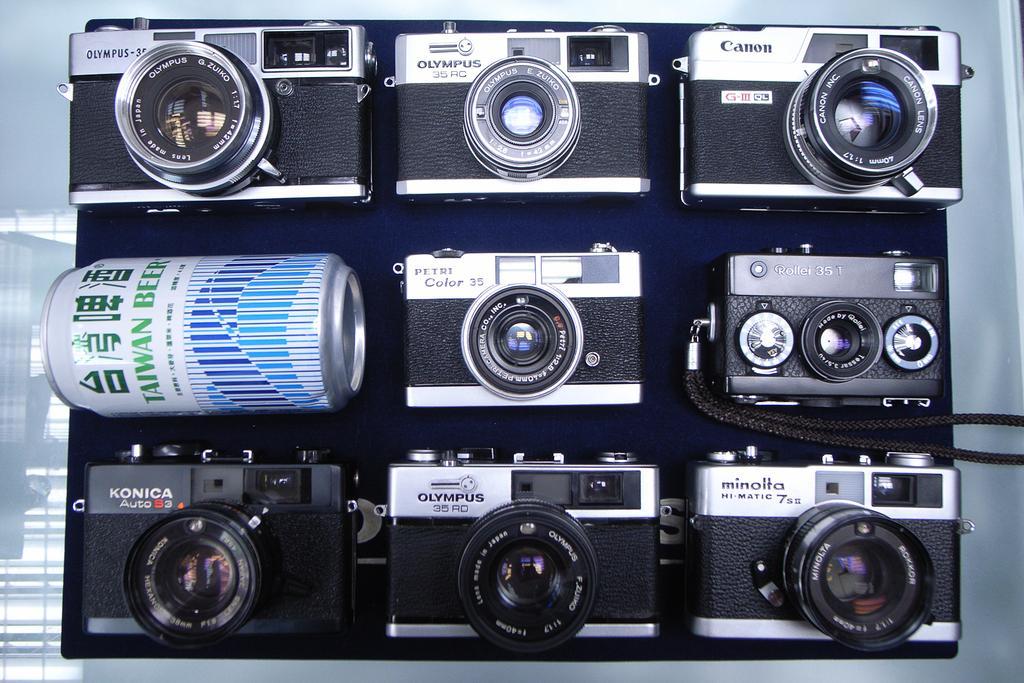Could you give a brief overview of what you see in this image? In this picture we can see cameras and a tin. 